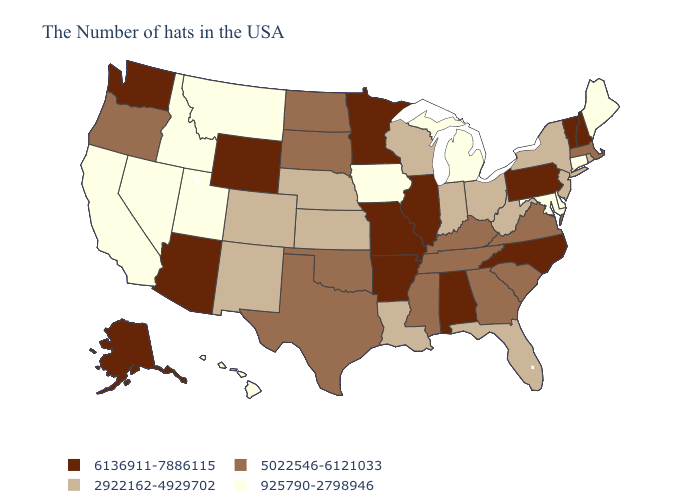Among the states that border Oklahoma , which have the lowest value?
Concise answer only. Kansas, Colorado, New Mexico. Which states hav the highest value in the MidWest?
Concise answer only. Illinois, Missouri, Minnesota. What is the lowest value in states that border Kansas?
Answer briefly. 2922162-4929702. Name the states that have a value in the range 6136911-7886115?
Be succinct. New Hampshire, Vermont, Pennsylvania, North Carolina, Alabama, Illinois, Missouri, Arkansas, Minnesota, Wyoming, Arizona, Washington, Alaska. What is the value of Idaho?
Give a very brief answer. 925790-2798946. Which states hav the highest value in the Northeast?
Concise answer only. New Hampshire, Vermont, Pennsylvania. What is the value of North Dakota?
Short answer required. 5022546-6121033. Does the map have missing data?
Short answer required. No. Name the states that have a value in the range 2922162-4929702?
Give a very brief answer. Rhode Island, New York, New Jersey, West Virginia, Ohio, Florida, Indiana, Wisconsin, Louisiana, Kansas, Nebraska, Colorado, New Mexico. Which states hav the highest value in the West?
Short answer required. Wyoming, Arizona, Washington, Alaska. Among the states that border Colorado , which have the highest value?
Concise answer only. Wyoming, Arizona. Which states have the lowest value in the USA?
Give a very brief answer. Maine, Connecticut, Delaware, Maryland, Michigan, Iowa, Utah, Montana, Idaho, Nevada, California, Hawaii. What is the value of Virginia?
Keep it brief. 5022546-6121033. How many symbols are there in the legend?
Keep it brief. 4. Does Minnesota have a higher value than North Carolina?
Concise answer only. No. 